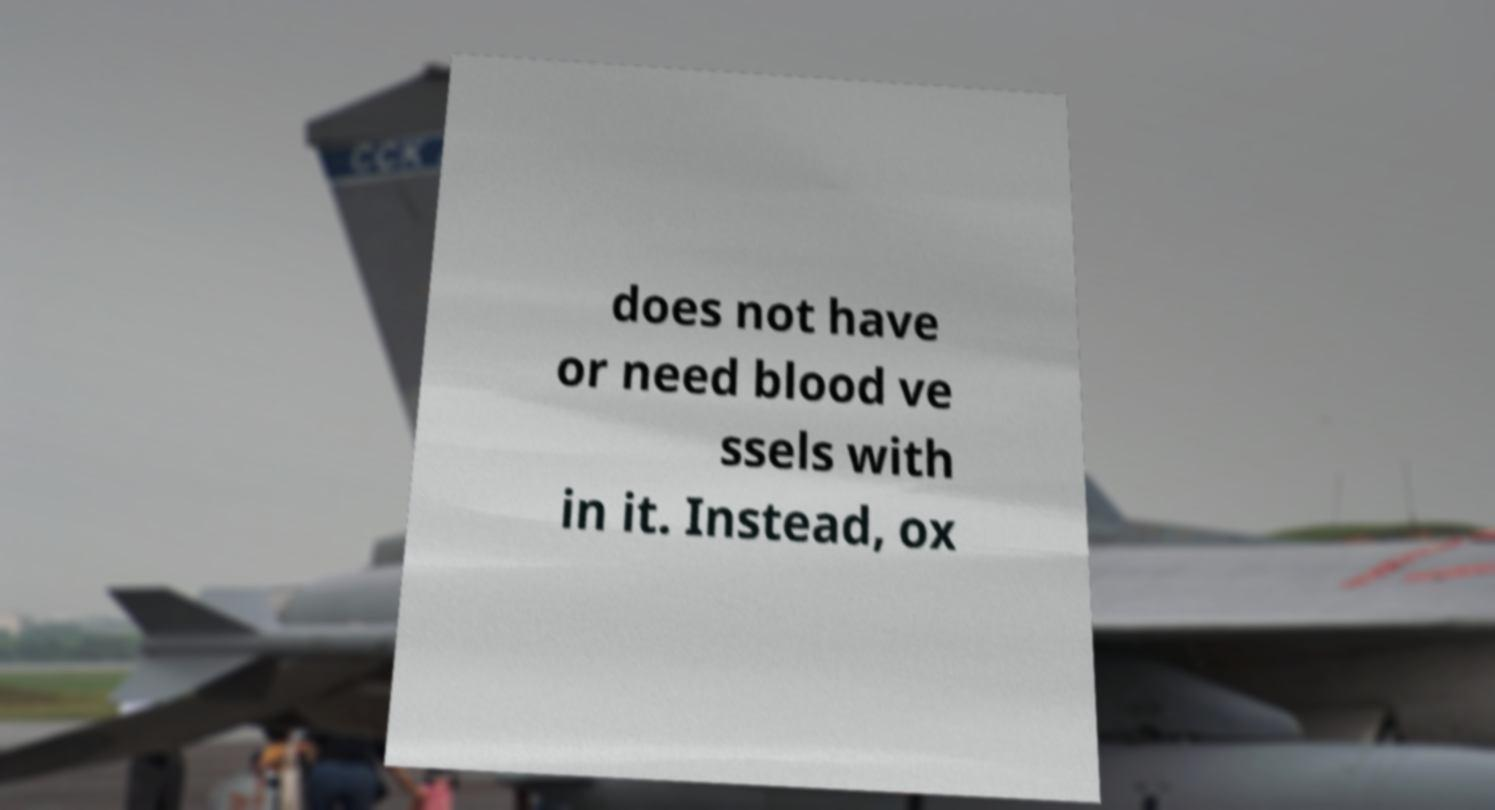Please read and relay the text visible in this image. What does it say? does not have or need blood ve ssels with in it. Instead, ox 